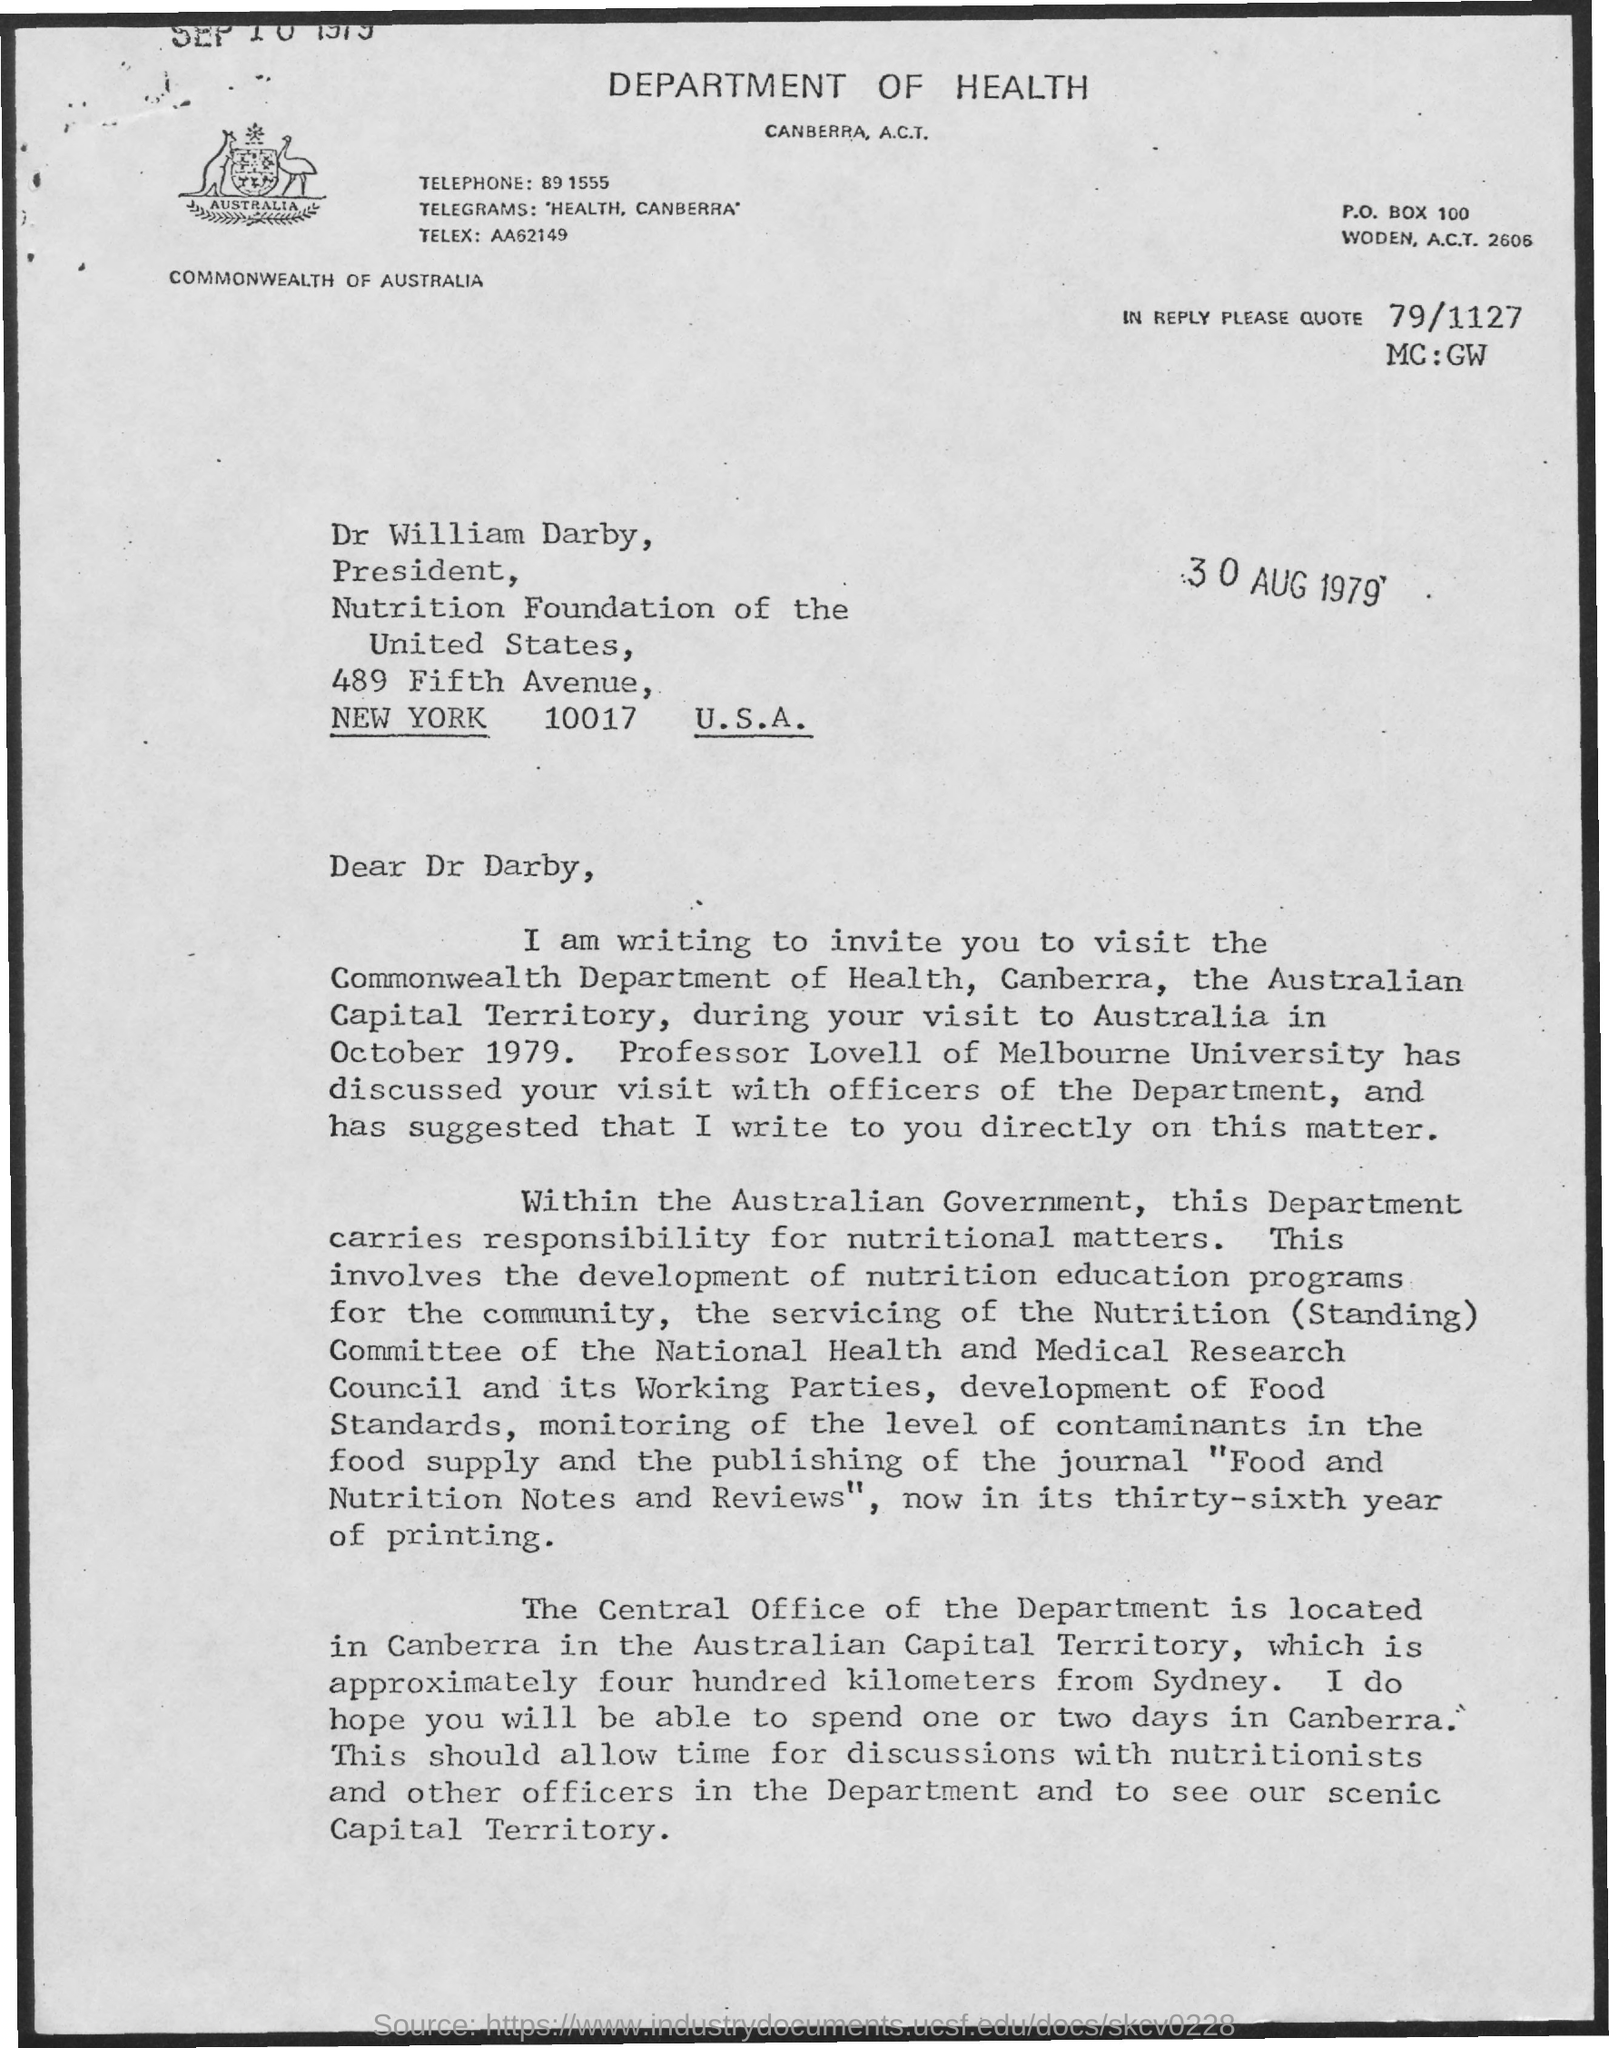What p.o box no ?
Make the answer very short. 100. Who is the president of nutrition foundation of united states ?
Give a very brief answer. Dr William Darby. What is the name of the city mentioned ?
Provide a short and direct response. New York. 